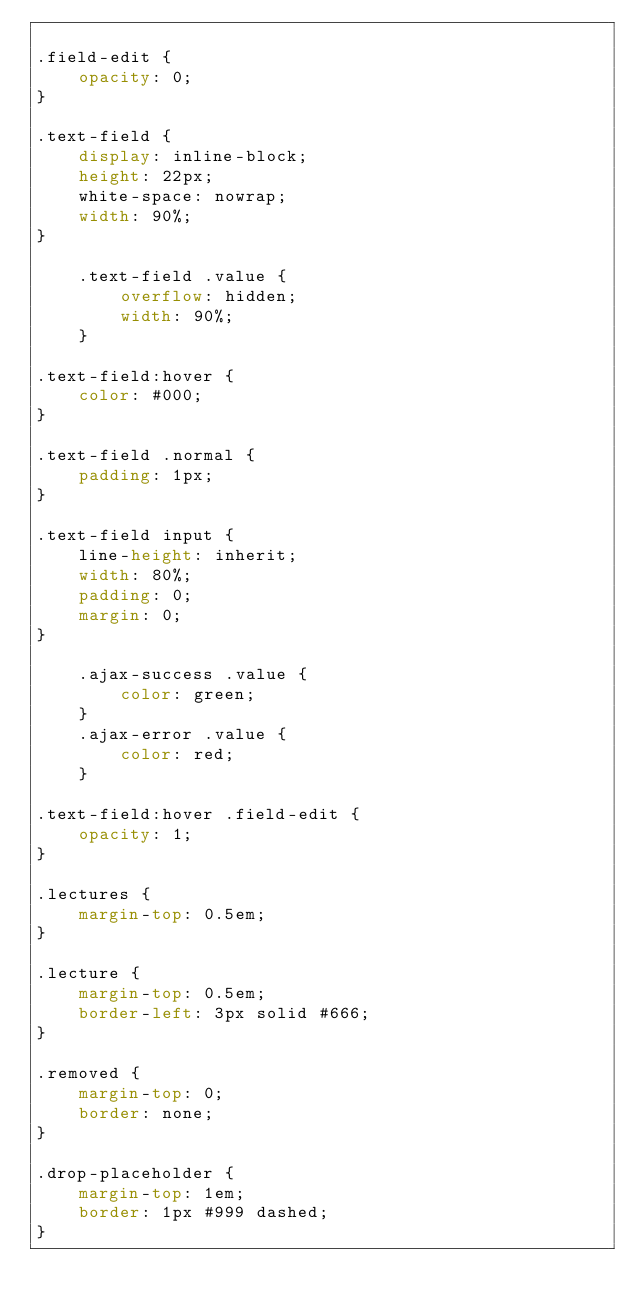<code> <loc_0><loc_0><loc_500><loc_500><_CSS_>
.field-edit {
    opacity: 0;
}

.text-field {
    display: inline-block;
    height: 22px;
    white-space: nowrap;
    width: 90%;
}

    .text-field .value {
        overflow: hidden;
        width: 90%;
    }

.text-field:hover {
    color: #000;
}

.text-field .normal {
    padding: 1px;
}

.text-field input {
    line-height: inherit;
    width: 80%;
    padding: 0;
    margin: 0;
}
    
    .ajax-success .value {
        color: green;
    }
    .ajax-error .value {
        color: red;
    }

.text-field:hover .field-edit {
    opacity: 1;
}

.lectures {
    margin-top: 0.5em;
}

.lecture {
    margin-top: 0.5em;
    border-left: 3px solid #666;
}

.removed {
    margin-top: 0;
    border: none;
}

.drop-placeholder {
    margin-top: 1em;
    border: 1px #999 dashed;
}</code> 